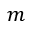Convert formula to latex. <formula><loc_0><loc_0><loc_500><loc_500>m</formula> 